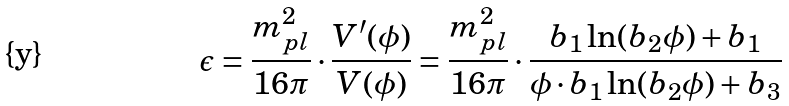<formula> <loc_0><loc_0><loc_500><loc_500>\epsilon = \frac { m ^ { 2 } _ { p l } } { 1 6 \pi } \cdot \frac { V ^ { \prime } ( \phi ) } { V ( \phi ) } = \frac { m ^ { 2 } _ { p l } } { 1 6 \pi } \cdot \frac { b _ { 1 } \ln ( b _ { 2 } \phi ) + b _ { 1 } } { \phi \cdot b _ { 1 } \ln ( b _ { 2 } \phi ) + b _ { 3 } }</formula> 